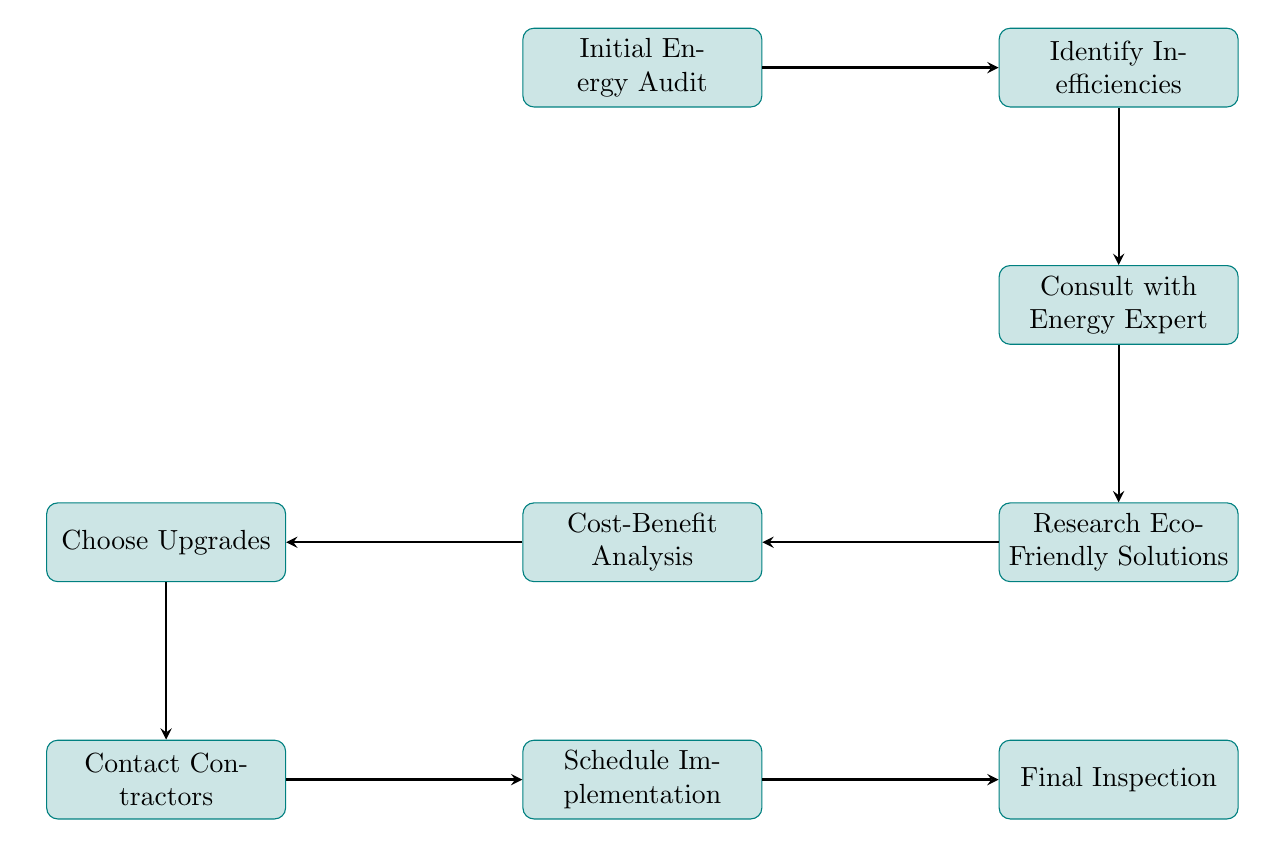What is the first step in the flowchart? The first step is represented by the initial node, which identifies the starting point of the process in the diagram, labeled as "Initial Energy Audit".
Answer: Initial Energy Audit How many nodes are there in the diagram? By counting each unique process depicted in the flowchart, there are a total of nine nodes present.
Answer: 9 What follows after "Identify Inefficiencies"? The flow of the chart is directional, and the immediate successor node that follows "Identify Inefficiencies" is labeled "Consult with Energy Expert".
Answer: Consult with Energy Expert What is the last step before the "Final Inspection"? The node preceding "Final Inspection" in the sequence is labeled "Schedule Implementation", indicating it is the final preparation step before the inspection.
Answer: Schedule Implementation Which node involves assessment of cost and savings? The node that specifically addresses the evaluation of cost and potential savings from upgrades is labeled "Cost-Benefit Analysis".
Answer: Cost-Benefit Analysis What type of professional should be consulted after identifying inefficiencies? The diagram indicates that one should consult a specific type of professional, detailed as "certified energy consultant", following the identification of inefficiencies.
Answer: Certified energy consultant What is the purpose of the "Research Eco-Friendly Solutions" step? This step aims to explore and identify environmentally friendly products and upgrades, making it crucial for environmentally conscious homeowners.
Answer: Explore environmentally friendly products and upgrades Which two nodes are directly connected by an arrow after the "Research Eco-Friendly Solutions"? The two nodes that are directly connected by an arrow after "Research Eco-Friendly Solutions" are "Cost-Benefit Analysis" and "Consult with Energy Expert".
Answer: Cost-Benefit Analysis and Consult with Energy Expert 